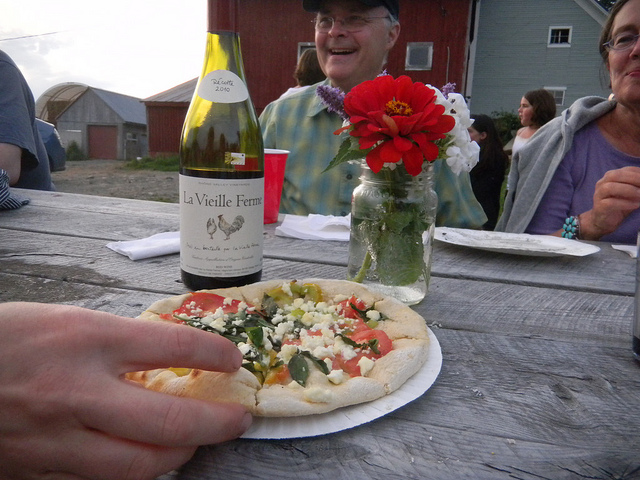Please transcribe the text in this image. La Vieille Ferm 